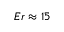<formula> <loc_0><loc_0><loc_500><loc_500>E r \approx 1 5</formula> 